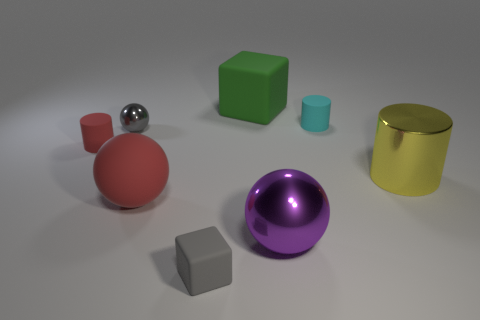Subtract all yellow metal cylinders. How many cylinders are left? 2 Add 1 large purple matte blocks. How many objects exist? 9 Subtract all gray spheres. How many spheres are left? 2 Subtract all cylinders. How many objects are left? 5 Subtract 1 blocks. How many blocks are left? 1 Subtract all gray cubes. Subtract all gray balls. How many cubes are left? 1 Subtract all brown cylinders. How many purple spheres are left? 1 Subtract all small red rubber cylinders. Subtract all small blue shiny objects. How many objects are left? 7 Add 3 green cubes. How many green cubes are left? 4 Add 7 rubber cylinders. How many rubber cylinders exist? 9 